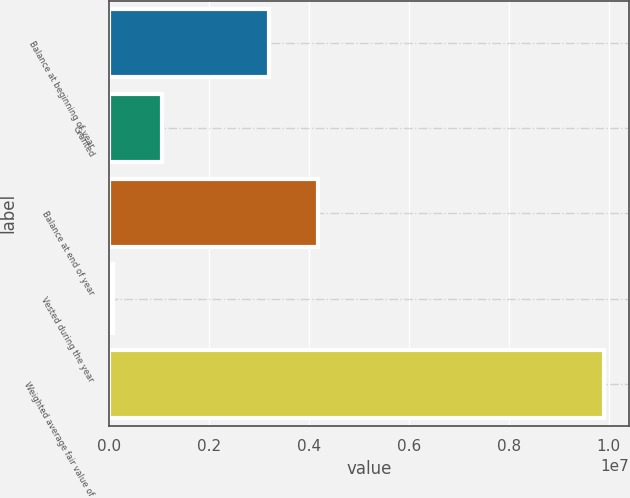<chart> <loc_0><loc_0><loc_500><loc_500><bar_chart><fcel>Balance at beginning of year<fcel>Granted<fcel>Balance at end of year<fcel>Vested during the year<fcel>Weighted average fair value of<nl><fcel>3.20203e+06<fcel>1.07676e+06<fcel>4.18306e+06<fcel>95736<fcel>9.90599e+06<nl></chart> 